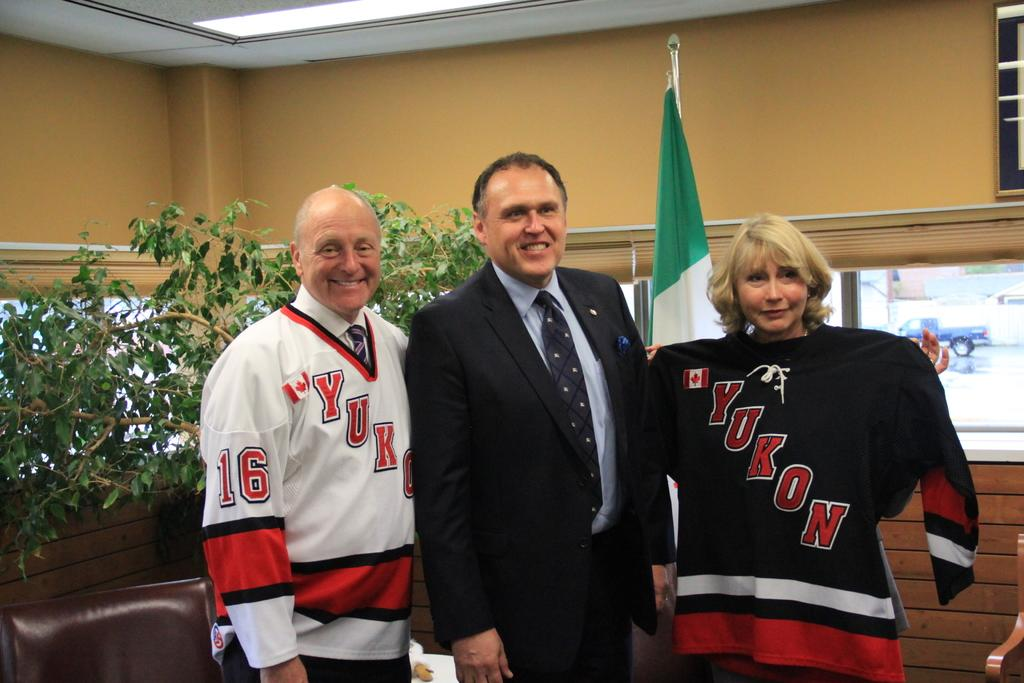Provide a one-sentence caption for the provided image. A man in a suit is posing with a man and woman in Yukon jerseys. 